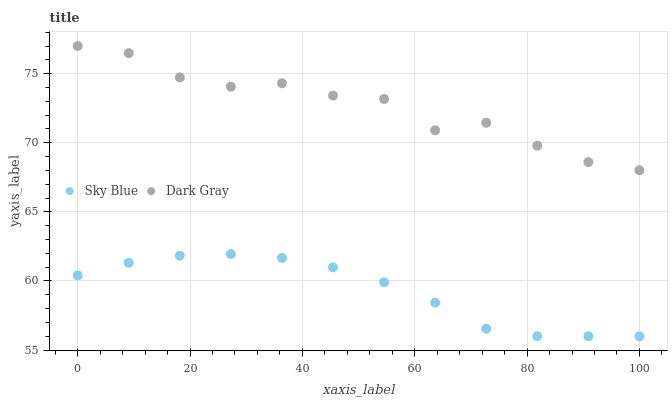Does Sky Blue have the minimum area under the curve?
Answer yes or no. Yes. Does Dark Gray have the maximum area under the curve?
Answer yes or no. Yes. Does Sky Blue have the maximum area under the curve?
Answer yes or no. No. Is Sky Blue the smoothest?
Answer yes or no. Yes. Is Dark Gray the roughest?
Answer yes or no. Yes. Is Sky Blue the roughest?
Answer yes or no. No. Does Sky Blue have the lowest value?
Answer yes or no. Yes. Does Dark Gray have the highest value?
Answer yes or no. Yes. Does Sky Blue have the highest value?
Answer yes or no. No. Is Sky Blue less than Dark Gray?
Answer yes or no. Yes. Is Dark Gray greater than Sky Blue?
Answer yes or no. Yes. Does Sky Blue intersect Dark Gray?
Answer yes or no. No. 